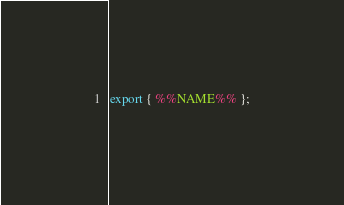<code> <loc_0><loc_0><loc_500><loc_500><_JavaScript_>export { %%NAME%% };
</code> 